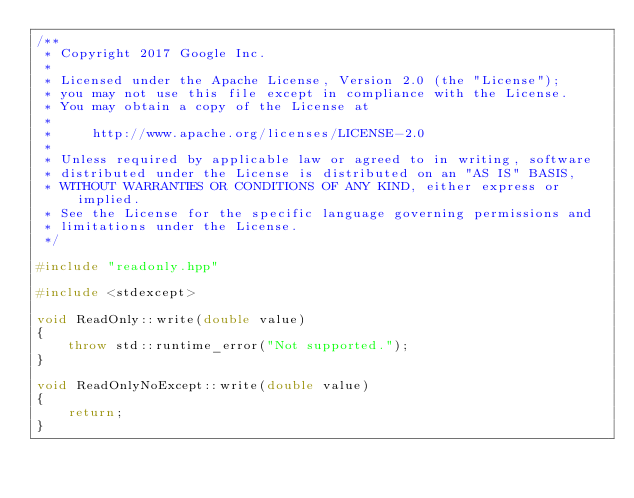Convert code to text. <code><loc_0><loc_0><loc_500><loc_500><_C++_>/**
 * Copyright 2017 Google Inc.
 *
 * Licensed under the Apache License, Version 2.0 (the "License");
 * you may not use this file except in compliance with the License.
 * You may obtain a copy of the License at
 *
 *     http://www.apache.org/licenses/LICENSE-2.0
 *
 * Unless required by applicable law or agreed to in writing, software
 * distributed under the License is distributed on an "AS IS" BASIS,
 * WITHOUT WARRANTIES OR CONDITIONS OF ANY KIND, either express or implied.
 * See the License for the specific language governing permissions and
 * limitations under the License.
 */

#include "readonly.hpp"

#include <stdexcept>

void ReadOnly::write(double value)
{
    throw std::runtime_error("Not supported.");
}

void ReadOnlyNoExcept::write(double value)
{
    return;
}
</code> 